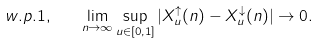Convert formula to latex. <formula><loc_0><loc_0><loc_500><loc_500>w . p . 1 , \quad \lim _ { n \rightarrow \infty } \sup _ { u \in [ 0 , 1 ] } | X ^ { \uparrow } _ { u } ( n ) - X ^ { \downarrow } _ { u } ( n ) | \rightarrow 0 .</formula> 